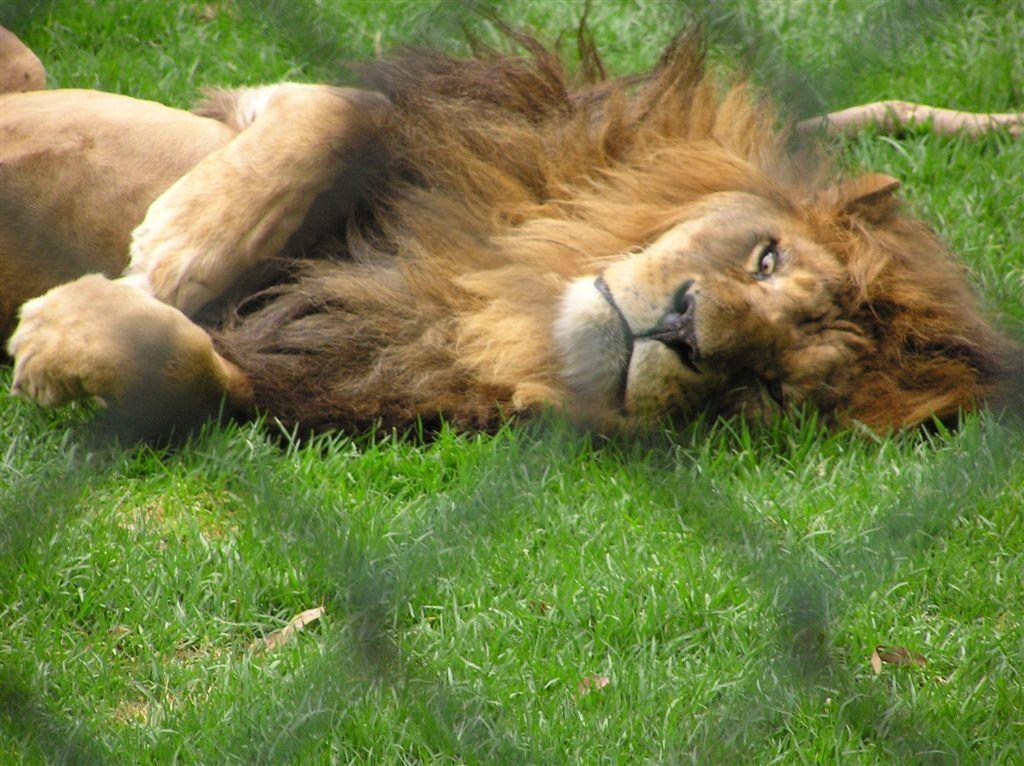What animal is in the center of the image? There is a lion in the center of the image. What can be seen in the foreground of the image? There is a net in the foreground of the image. What type of vegetation is at the bottom of the image? There is grass at the bottom of the image. What type of wheel is visible in the image? There is no wheel present in the image. Can you describe the substance that the lion is standing on? The lion is standing on grass, which is a type of vegetation, not a substance. 